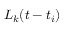Convert formula to latex. <formula><loc_0><loc_0><loc_500><loc_500>L _ { k } ( t - t _ { i } )</formula> 